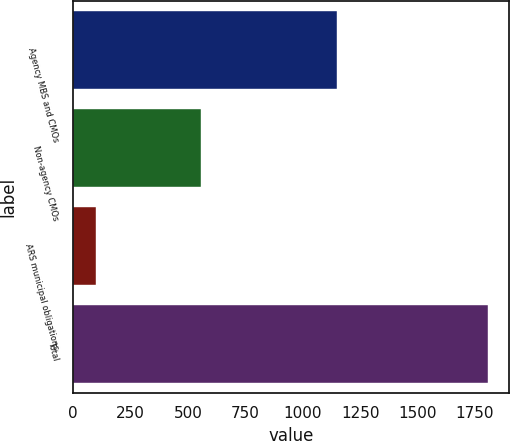<chart> <loc_0><loc_0><loc_500><loc_500><bar_chart><fcel>Agency MBS and CMOs<fcel>Non-agency CMOs<fcel>ARS municipal obligations<fcel>Total<nl><fcel>1150<fcel>556<fcel>100<fcel>1806<nl></chart> 